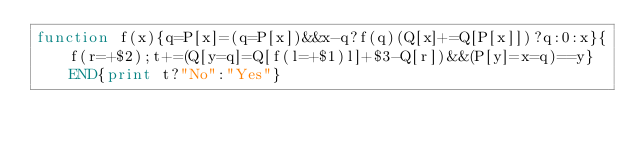Convert code to text. <code><loc_0><loc_0><loc_500><loc_500><_Awk_>function f(x){q=P[x]=(q=P[x])&&x-q?f(q)(Q[x]+=Q[P[x]])?q:0:x}{f(r=+$2);t+=(Q[y=q]=Q[f(l=+$1)l]+$3-Q[r])&&(P[y]=x=q)==y}END{print t?"No":"Yes"}</code> 